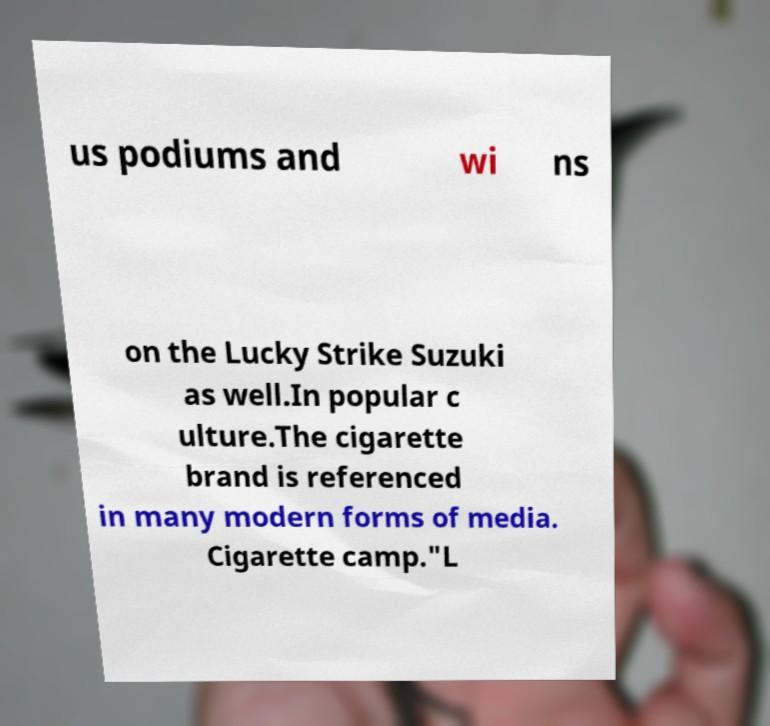Can you accurately transcribe the text from the provided image for me? us podiums and wi ns on the Lucky Strike Suzuki as well.In popular c ulture.The cigarette brand is referenced in many modern forms of media. Cigarette camp."L 